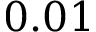<formula> <loc_0><loc_0><loc_500><loc_500>0 . 0 1</formula> 